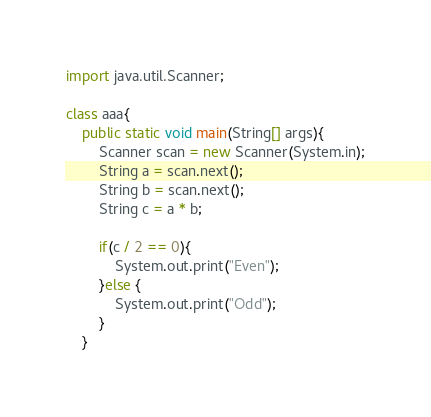Convert code to text. <code><loc_0><loc_0><loc_500><loc_500><_Java_>import java.util.Scanner;
 
class aaa{
	public static void main(String[] args){
		Scanner scan = new Scanner(System.in);
        String a = scan.next();
        String b = scan.next();
        String c = a * b;
        
        if(c / 2 == 0){
        	System.out.print("Even");
        }else {
        	System.out.print("Odd");
        }
    }</code> 